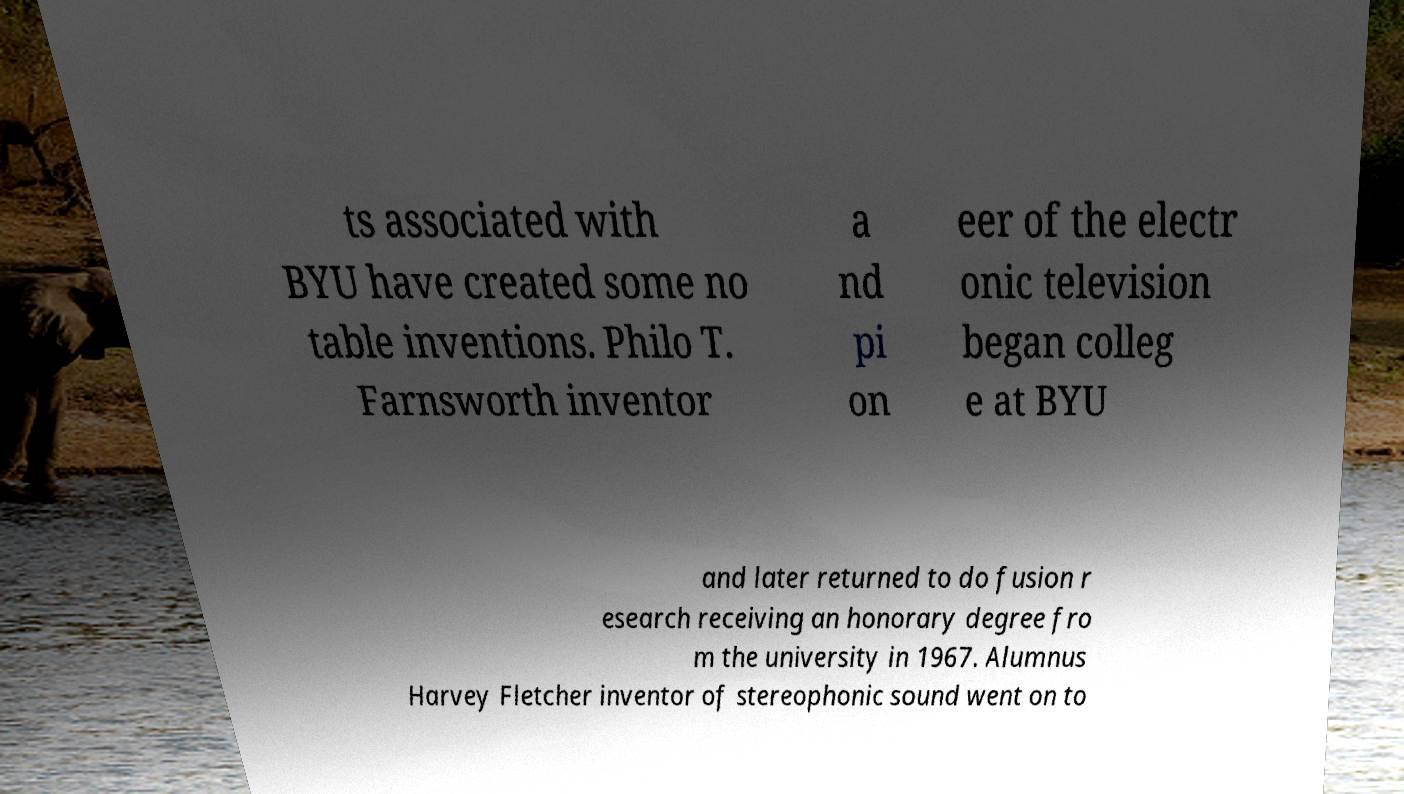Please read and relay the text visible in this image. What does it say? ts associated with BYU have created some no table inventions. Philo T. Farnsworth inventor a nd pi on eer of the electr onic television began colleg e at BYU and later returned to do fusion r esearch receiving an honorary degree fro m the university in 1967. Alumnus Harvey Fletcher inventor of stereophonic sound went on to 